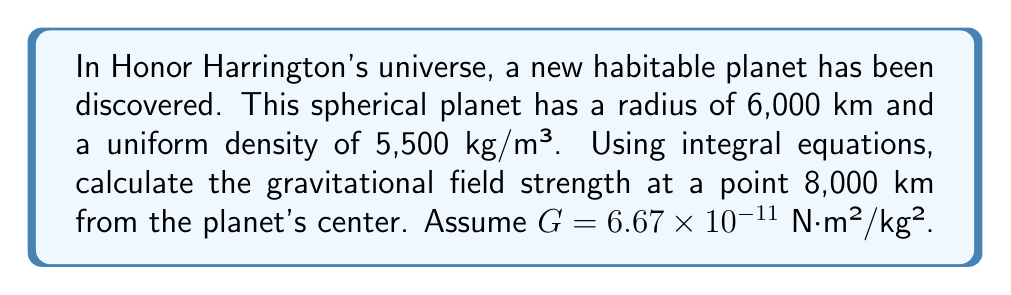What is the answer to this math problem? Let's approach this step-by-step:

1) The gravitational field strength at a point outside a spherical body can be calculated using the integral equation:

   $$g(r) = G \int_0^R \frac{4\pi\rho r'^2}{r^2} dr'$$

   where $G$ is the gravitational constant, $\rho$ is the density, $R$ is the radius of the planet, and $r$ is the distance from the center to the point of interest.

2) Given:
   - $G = 6.67 \times 10^{-11}$ N·m²/kg²
   - $\rho = 5,500$ kg/m³
   - $R = 6,000,000$ m
   - $r = 8,000,000$ m

3) Substituting these values into the integral:

   $$g(r) = 6.67 \times 10^{-11} \int_0^{6,000,000} \frac{4\pi \cdot 5,500 \cdot r'^2}{(8,000,000)^2} dr'$$

4) Simplify the constant terms:

   $$g(r) = \frac{6.67 \times 10^{-11} \cdot 4\pi \cdot 5,500}{64 \times 10^{12}} \int_0^{6,000,000} r'^2 dr'$$

5) Evaluate the integral:

   $$g(r) = \frac{6.67 \times 10^{-11} \cdot 4\pi \cdot 5,500}{64 \times 10^{12}} \cdot \frac{r'^3}{3} \bigg|_0^{6,000,000}$$

6) Solve:

   $$g(r) = \frac{6.67 \times 10^{-11} \cdot 4\pi \cdot 5,500}{64 \times 10^{12}} \cdot \frac{(6,000,000)^3}{3}$$

7) Calculate the final value:

   $$g(r) \approx 7.40 \text{ m/s²}$$
Answer: $7.40 \text{ m/s²}$ 